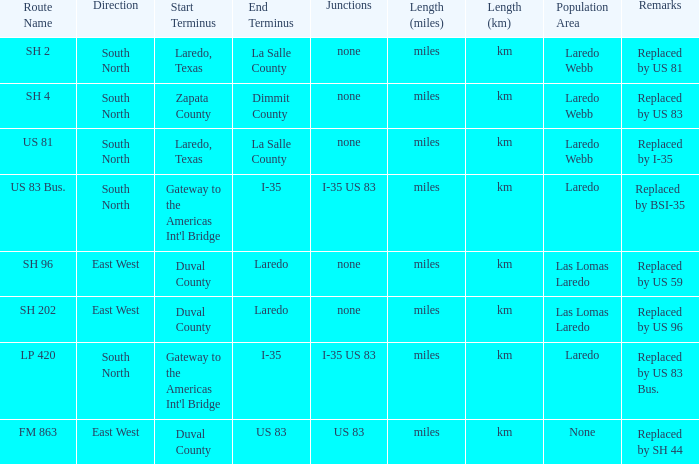Which population areas have "replaced by us 83" listed in their remarks section? Laredo Webb. 